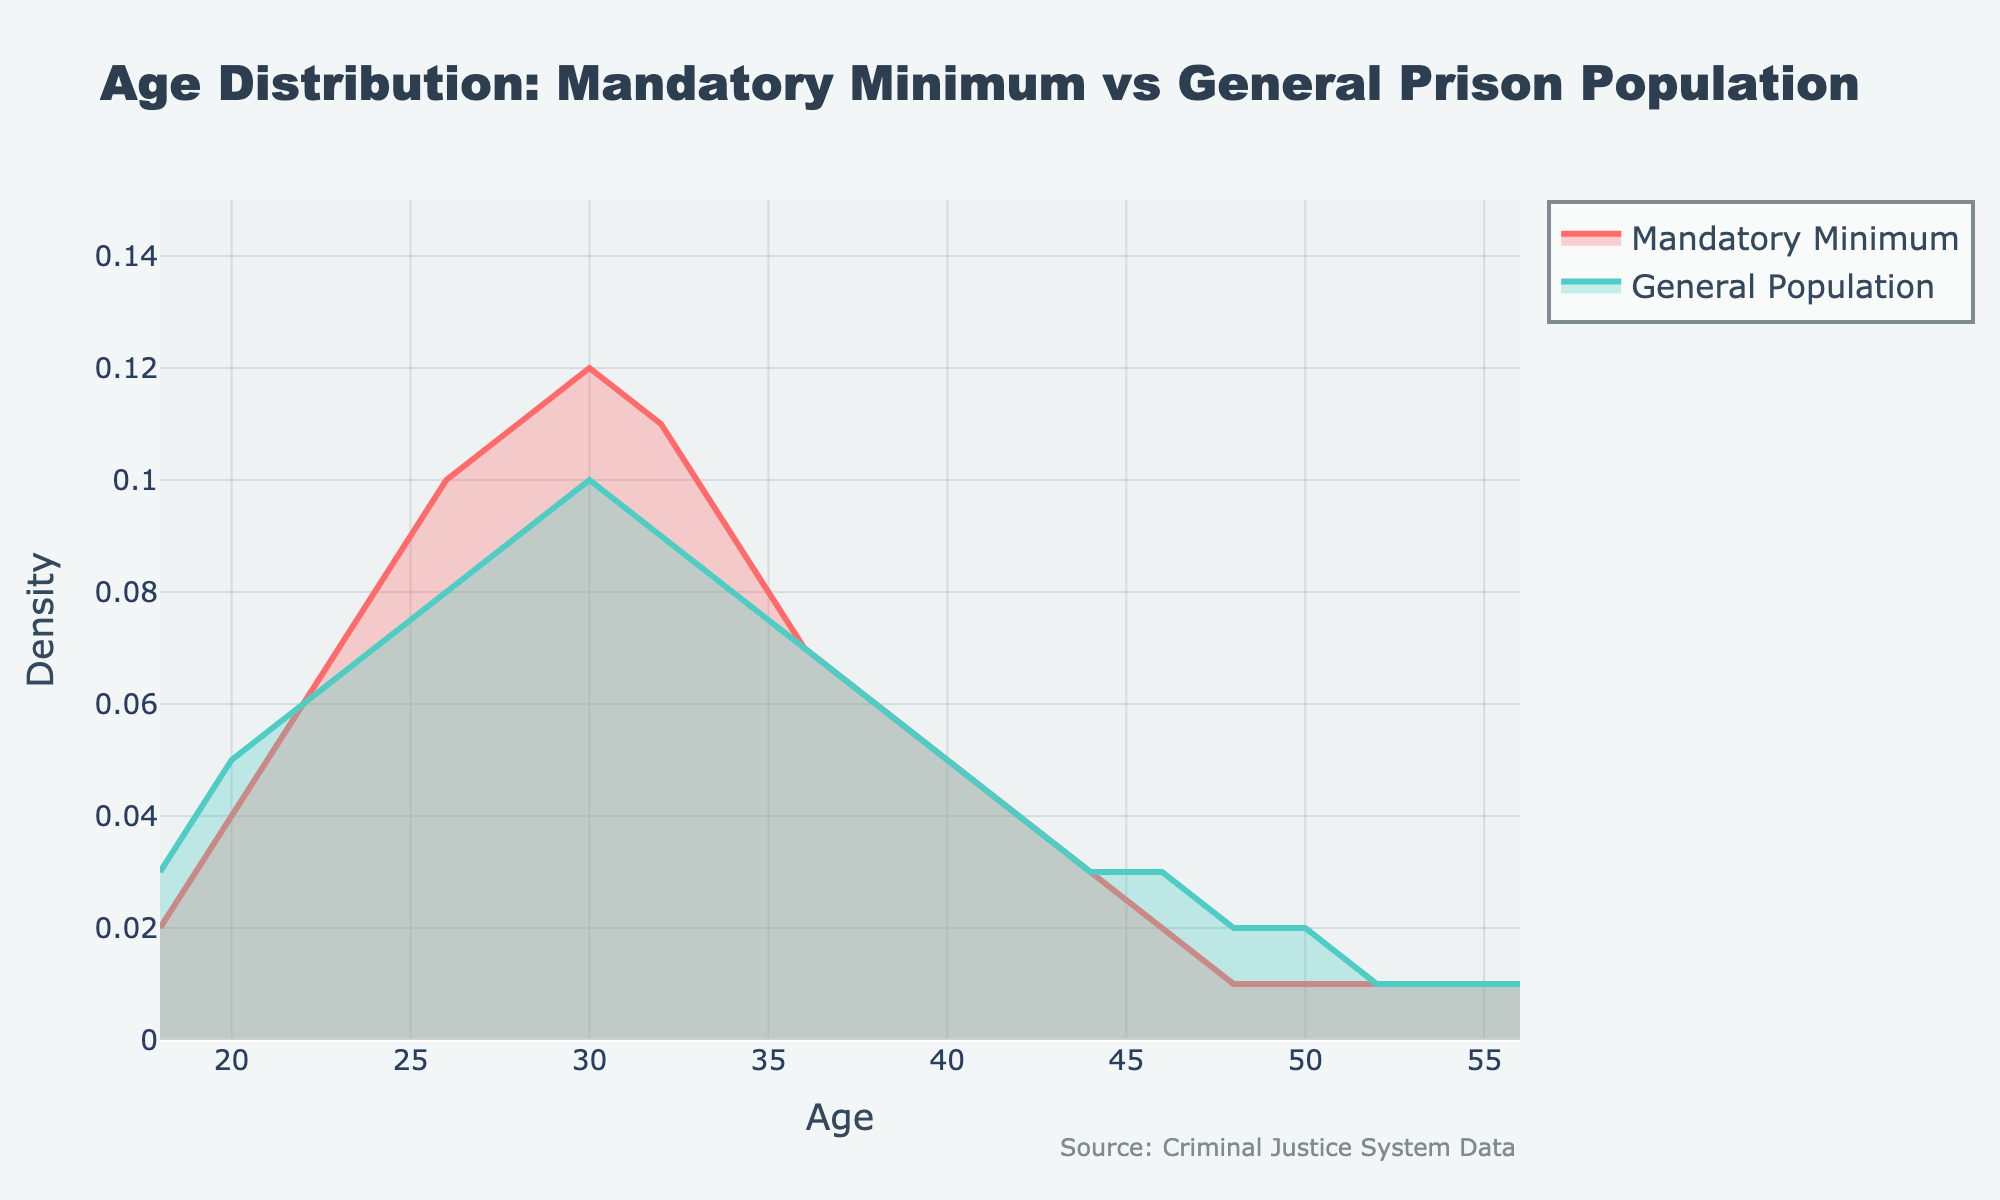What's the title of the figure? To find the title, look at the top center part of the figure where the textual information is provided. The title is usually the largest text.
Answer: Age Distribution: Mandatory Minimum vs General Prison Population What are the fill colors used for the two density plots? To identify the fill colors, observe the areas under the curves. The colors are used to differentiate the two groups.
Answer: The fill color for the Mandatory Minimum is a shade of red, and for the General Population is a shade of green At what age range do both distributions start to decline? Observe the peaks of both curves and identify where they start to decrease on the x-axis, noting the age ranges before the declines.
Answer: After age 30, both distributions start to decline Which age group has the highest density in the Mandatory Minimum plot? Look at the Mandatory Minimum curve and find the highest point. Then refer to the x-axis to determine the corresponding age group.
Answer: The age group around 30 years old Is there an age group where the density of the General Population is higher than the Mandatory Minimum? Compare the two density plots at various age ranges to identify any segments where the General Population density surpasses the Mandatory Minimum.
Answer: Yes, around ages 46-48 and 50-52 What is the general trend of the density for the age group 18-28 in the Mandatory Minimum curve? Observe the curve representing the Mandatory Minimum from age 18 to 28 and describe the overall direction it takes (increasing, decreasing, or stable).
Answer: Increasing How does the density of defendants facing mandatory minimum sentences at age 34 compare to the general prison population at the same age? Compare the y-values of both curves at age 34 to see which is higher.
Answer: The density of defendants facing mandatory minimum sentences is slightly higher What is the range of the y-axis? Look at the y-axis and identify the minimum and maximum values shown to understand the density range displayed.
Answer: 0 to 0.15 Which population shows a quicker decrease in density after the peak age, Mandatory Minimum or General Population? Observe the slopes of the curves immediately after their peaks; the steeper slope indicates a quicker decrease.
Answer: Mandatory Minimum 